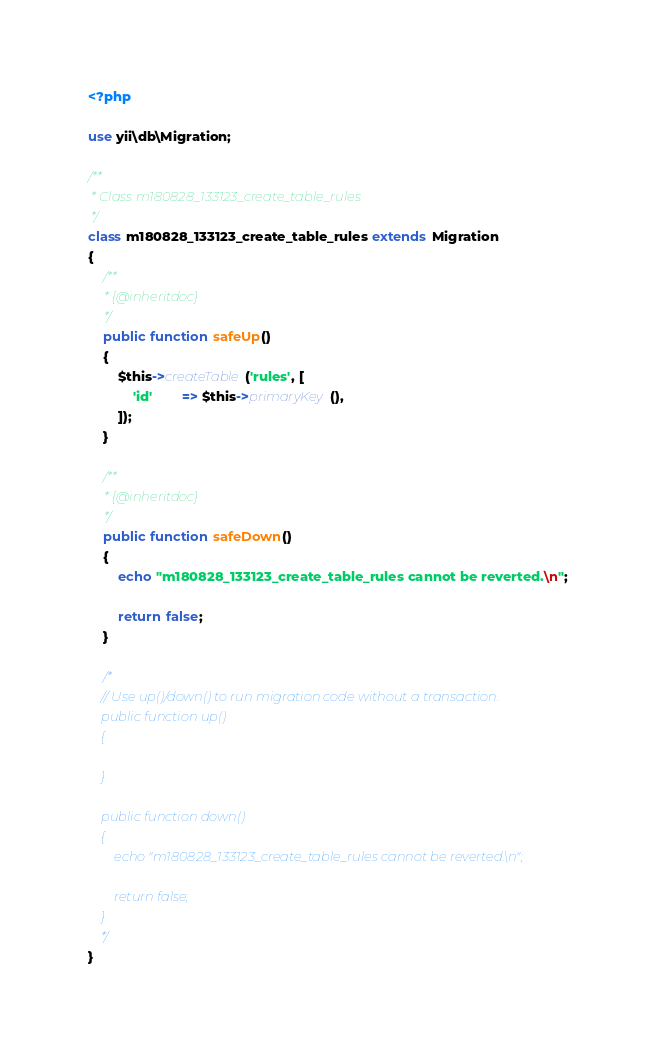<code> <loc_0><loc_0><loc_500><loc_500><_PHP_><?php

use yii\db\Migration;

/**
 * Class m180828_133123_create_table_rules
 */
class m180828_133123_create_table_rules extends Migration
{
    /**
     * {@inheritdoc}
     */
    public function safeUp()
    {
        $this->createTable('rules', [
            'id'        => $this->primaryKey(),
        ]);
    }

    /**
     * {@inheritdoc}
     */
    public function safeDown()
    {
        echo "m180828_133123_create_table_rules cannot be reverted.\n";

        return false;
    }

    /*
    // Use up()/down() to run migration code without a transaction.
    public function up()
    {

    }

    public function down()
    {
        echo "m180828_133123_create_table_rules cannot be reverted.\n";

        return false;
    }
    */
}
</code> 